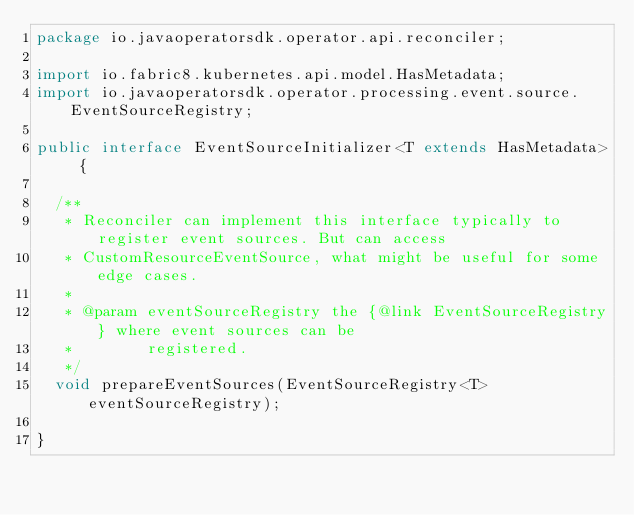<code> <loc_0><loc_0><loc_500><loc_500><_Java_>package io.javaoperatorsdk.operator.api.reconciler;

import io.fabric8.kubernetes.api.model.HasMetadata;
import io.javaoperatorsdk.operator.processing.event.source.EventSourceRegistry;

public interface EventSourceInitializer<T extends HasMetadata> {

  /**
   * Reconciler can implement this interface typically to register event sources. But can access
   * CustomResourceEventSource, what might be useful for some edge cases.
   * 
   * @param eventSourceRegistry the {@link EventSourceRegistry} where event sources can be
   *        registered.
   */
  void prepareEventSources(EventSourceRegistry<T> eventSourceRegistry);

}
</code> 